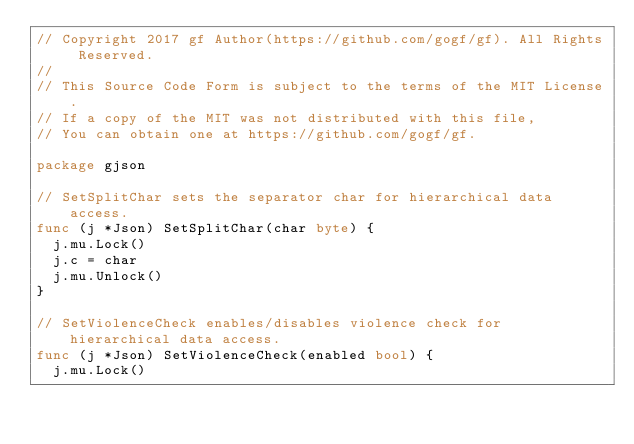Convert code to text. <code><loc_0><loc_0><loc_500><loc_500><_Go_>// Copyright 2017 gf Author(https://github.com/gogf/gf). All Rights Reserved.
//
// This Source Code Form is subject to the terms of the MIT License.
// If a copy of the MIT was not distributed with this file,
// You can obtain one at https://github.com/gogf/gf.

package gjson

// SetSplitChar sets the separator char for hierarchical data access.
func (j *Json) SetSplitChar(char byte) {
	j.mu.Lock()
	j.c = char
	j.mu.Unlock()
}

// SetViolenceCheck enables/disables violence check for hierarchical data access.
func (j *Json) SetViolenceCheck(enabled bool) {
	j.mu.Lock()</code> 